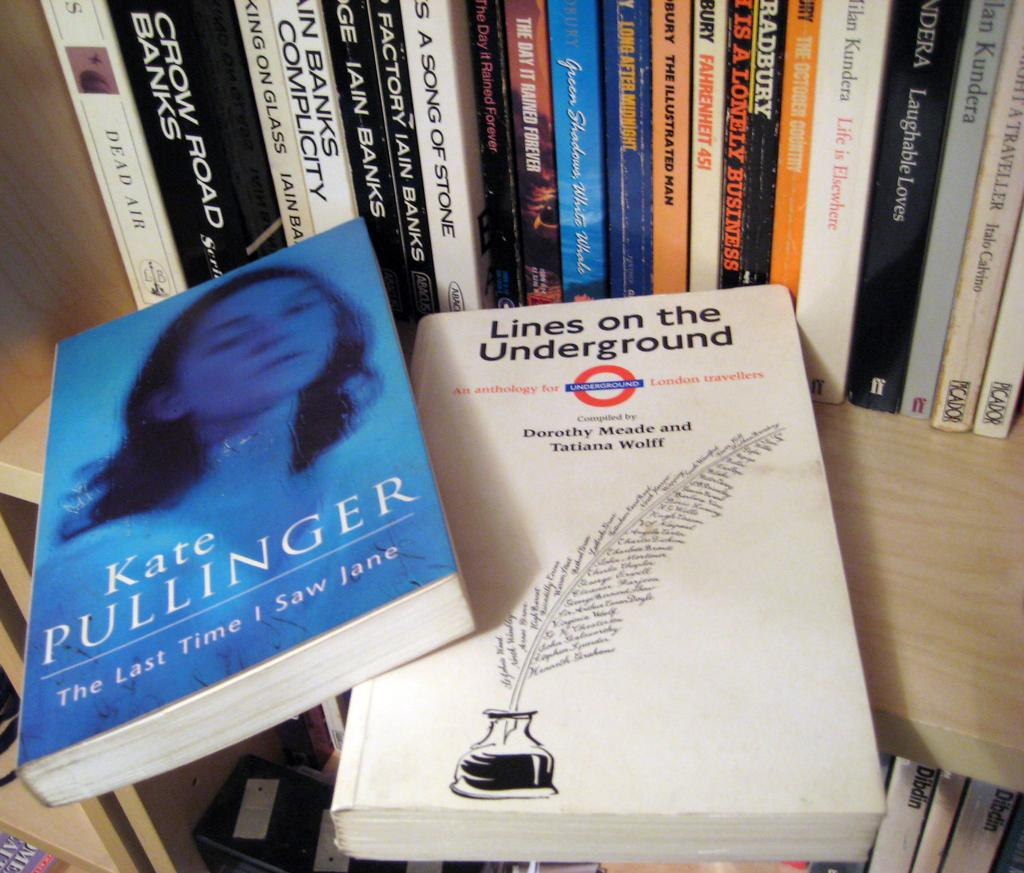<image>
Share a concise interpretation of the image provided. Various books on a shelf including Kate Pullinger's The Last Time I Saw Jane 